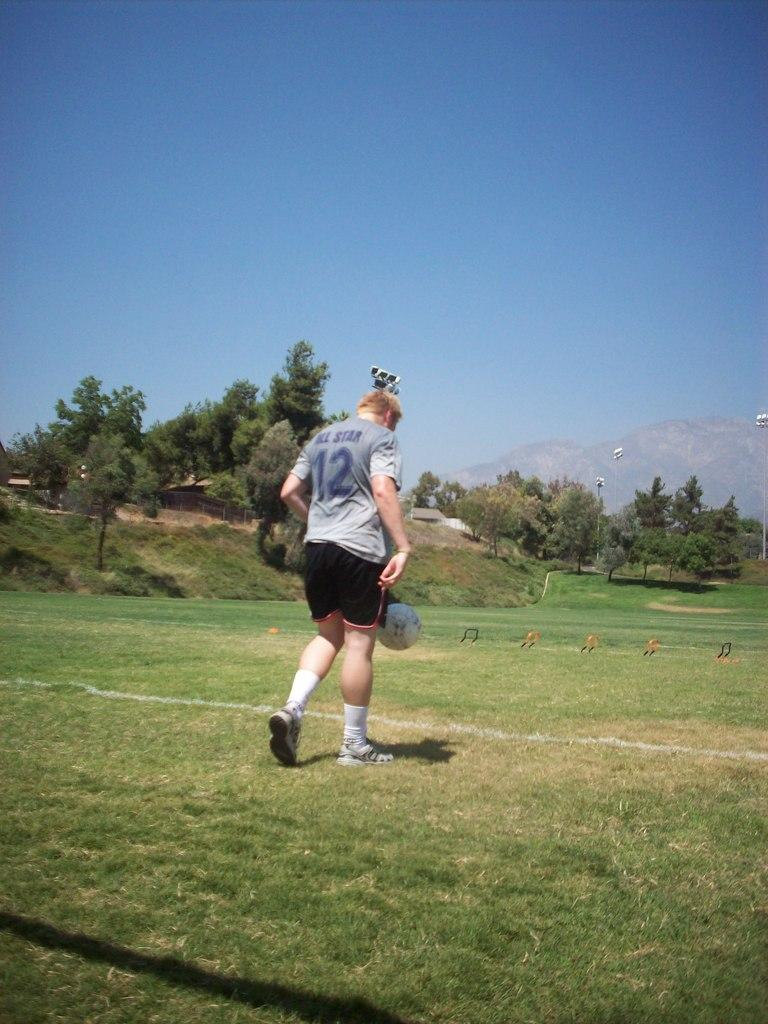<image>
Write a terse but informative summary of the picture. A player wearing a grey All Star jersey gets ready to kick a soccer ball. 